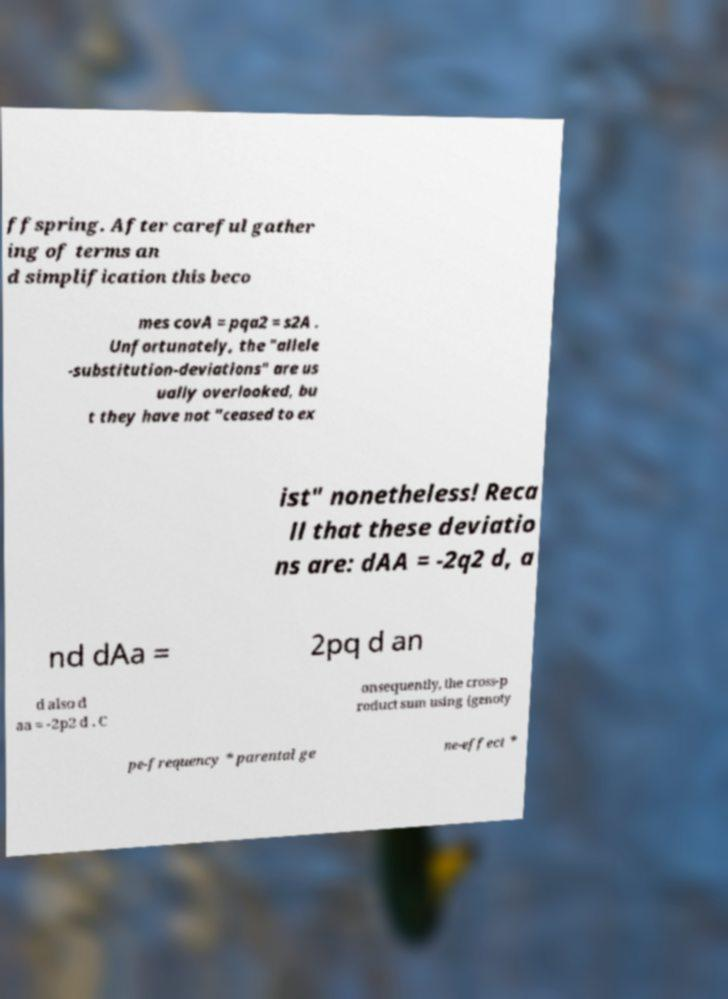Could you extract and type out the text from this image? ffspring. After careful gather ing of terms an d simplification this beco mes covA = pqa2 = s2A . Unfortunately, the "allele -substitution-deviations" are us ually overlooked, bu t they have not "ceased to ex ist" nonetheless! Reca ll that these deviatio ns are: dAA = -2q2 d, a nd dAa = 2pq d an d also d aa = -2p2 d . C onsequently, the cross-p roduct sum using {genoty pe-frequency * parental ge ne-effect * 